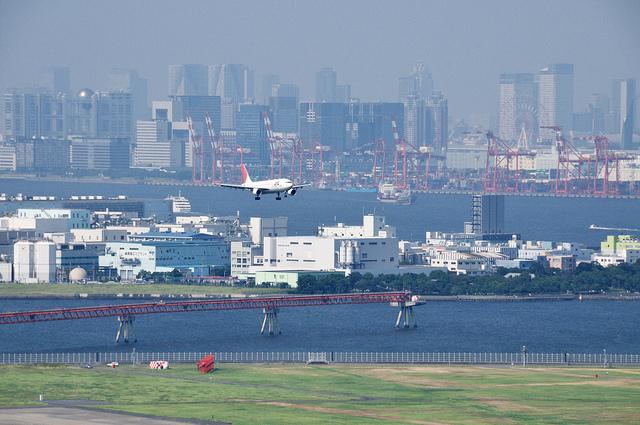Is the plane landing or taking off?
Write a very short answer. Landing. Would the city in the background be considered large?
Quick response, please. Yes. Is the sky clear?
Give a very brief answer. No. 